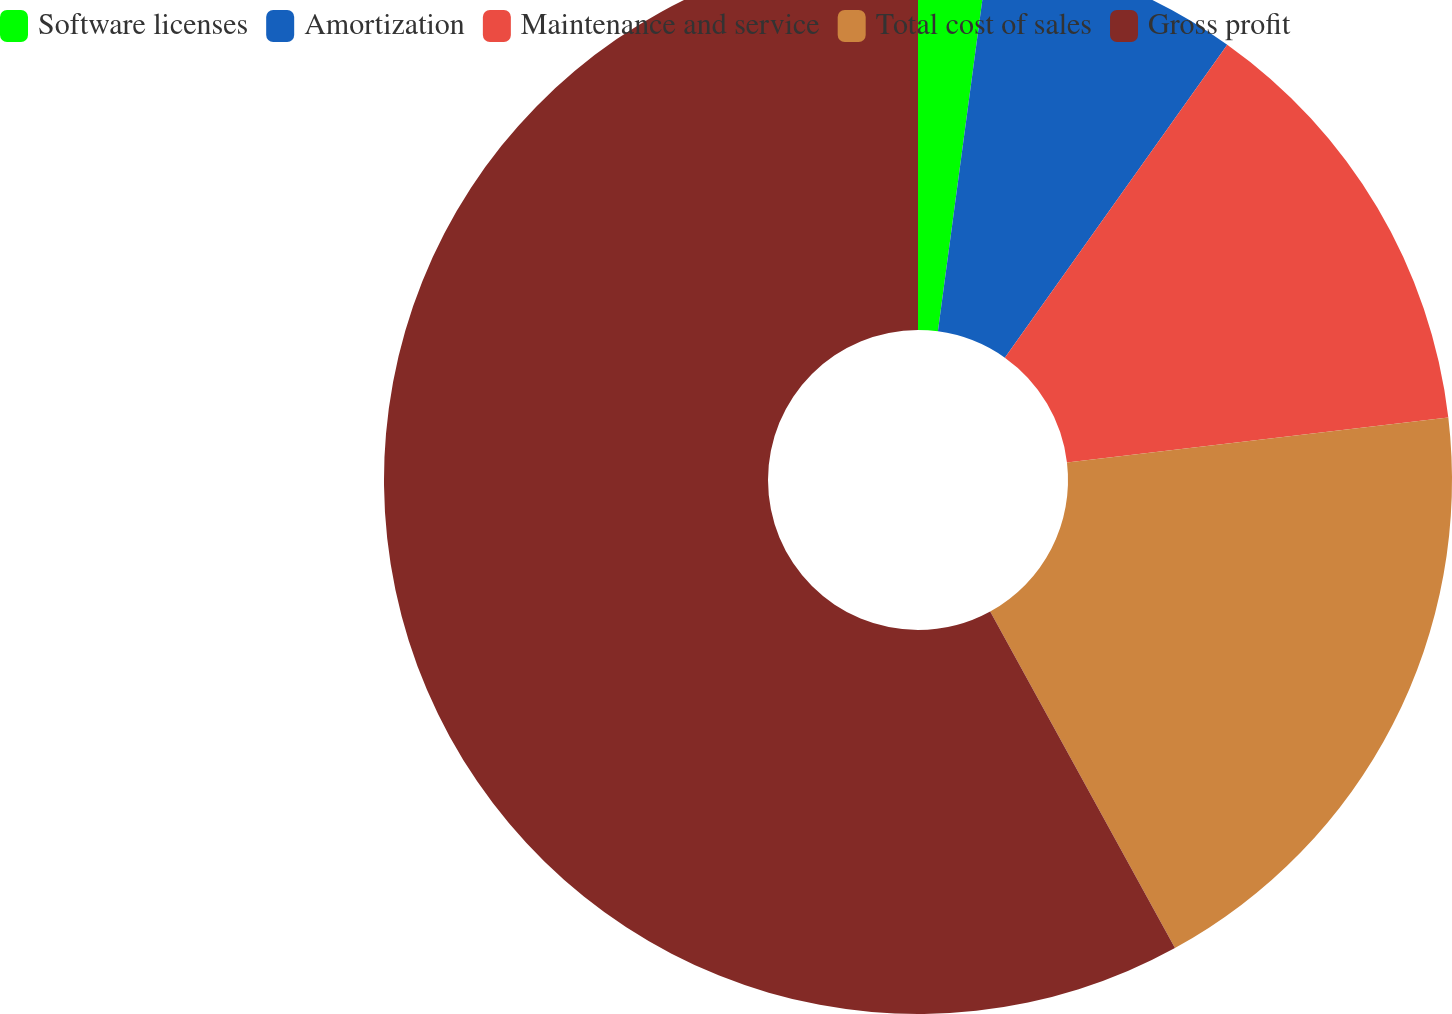Convert chart to OTSL. <chart><loc_0><loc_0><loc_500><loc_500><pie_chart><fcel>Software licenses<fcel>Amortization<fcel>Maintenance and service<fcel>Total cost of sales<fcel>Gross profit<nl><fcel>2.12%<fcel>7.71%<fcel>13.3%<fcel>18.88%<fcel>57.99%<nl></chart> 